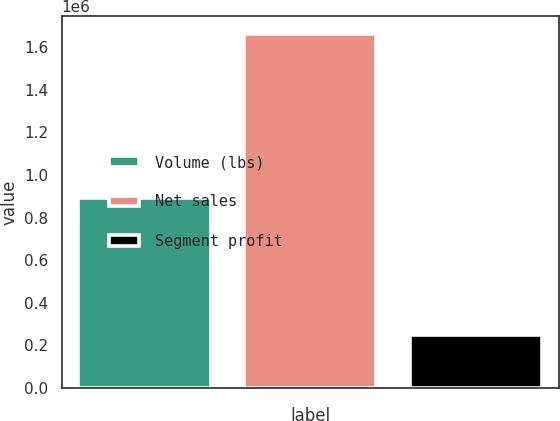<chart> <loc_0><loc_0><loc_500><loc_500><bar_chart><fcel>Volume (lbs)<fcel>Net sales<fcel>Segment profit<nl><fcel>890518<fcel>1.66316e+06<fcel>247322<nl></chart> 